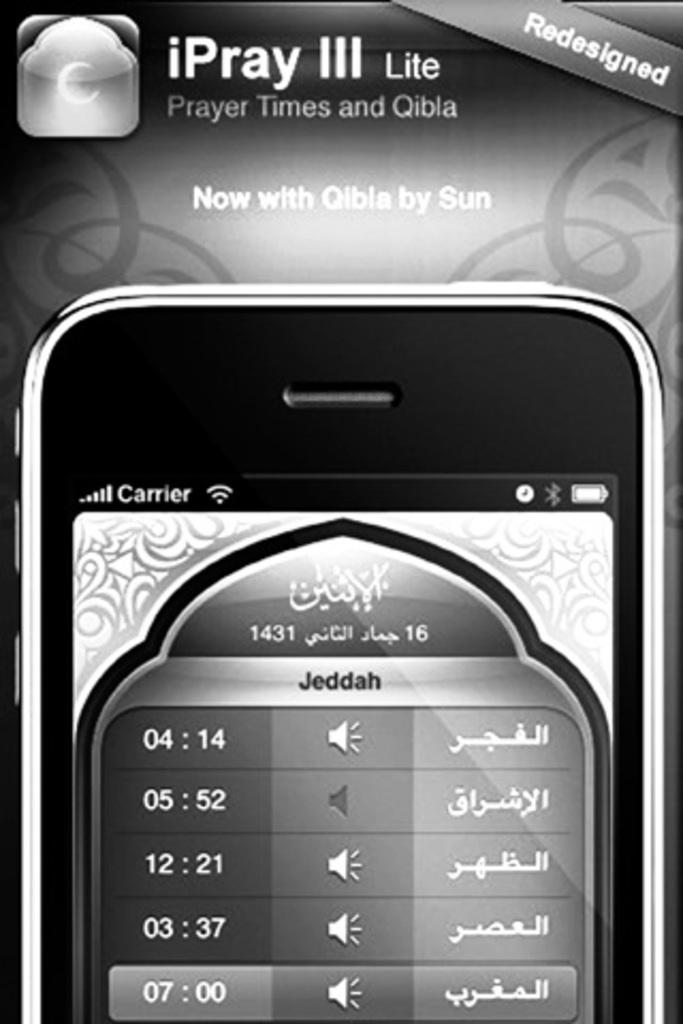What is the name of the app?
Offer a very short reply. Ipray iii lite. 